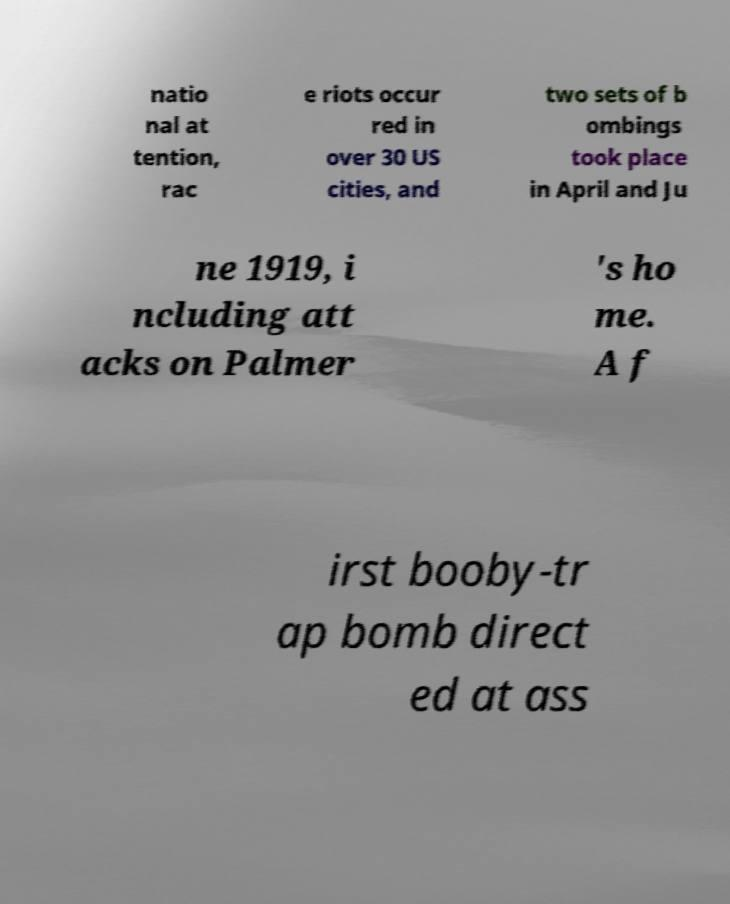Please identify and transcribe the text found in this image. natio nal at tention, rac e riots occur red in over 30 US cities, and two sets of b ombings took place in April and Ju ne 1919, i ncluding att acks on Palmer 's ho me. A f irst booby-tr ap bomb direct ed at ass 